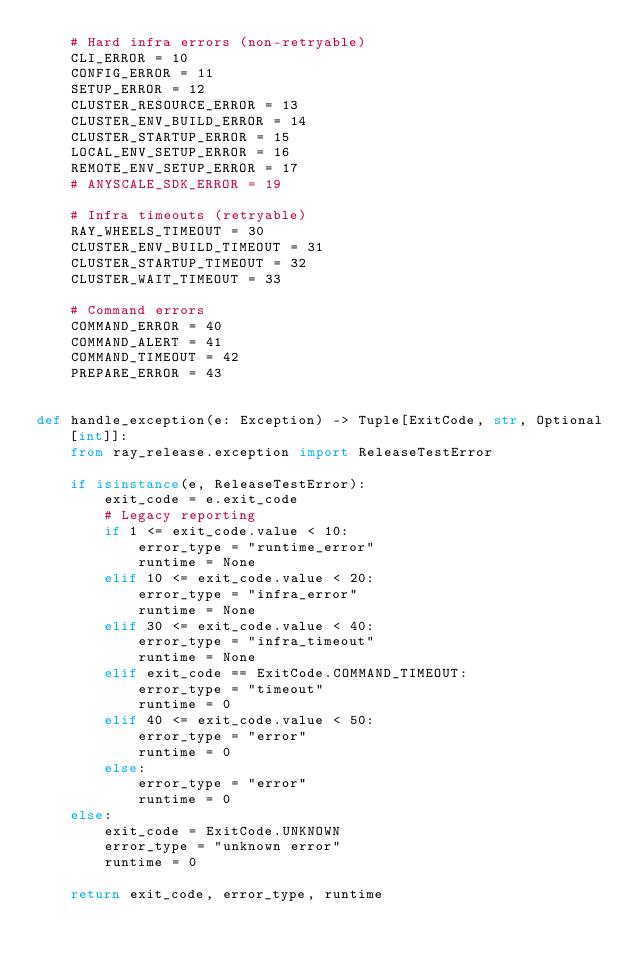<code> <loc_0><loc_0><loc_500><loc_500><_Python_>    # Hard infra errors (non-retryable)
    CLI_ERROR = 10
    CONFIG_ERROR = 11
    SETUP_ERROR = 12
    CLUSTER_RESOURCE_ERROR = 13
    CLUSTER_ENV_BUILD_ERROR = 14
    CLUSTER_STARTUP_ERROR = 15
    LOCAL_ENV_SETUP_ERROR = 16
    REMOTE_ENV_SETUP_ERROR = 17
    # ANYSCALE_SDK_ERROR = 19

    # Infra timeouts (retryable)
    RAY_WHEELS_TIMEOUT = 30
    CLUSTER_ENV_BUILD_TIMEOUT = 31
    CLUSTER_STARTUP_TIMEOUT = 32
    CLUSTER_WAIT_TIMEOUT = 33

    # Command errors
    COMMAND_ERROR = 40
    COMMAND_ALERT = 41
    COMMAND_TIMEOUT = 42
    PREPARE_ERROR = 43


def handle_exception(e: Exception) -> Tuple[ExitCode, str, Optional[int]]:
    from ray_release.exception import ReleaseTestError

    if isinstance(e, ReleaseTestError):
        exit_code = e.exit_code
        # Legacy reporting
        if 1 <= exit_code.value < 10:
            error_type = "runtime_error"
            runtime = None
        elif 10 <= exit_code.value < 20:
            error_type = "infra_error"
            runtime = None
        elif 30 <= exit_code.value < 40:
            error_type = "infra_timeout"
            runtime = None
        elif exit_code == ExitCode.COMMAND_TIMEOUT:
            error_type = "timeout"
            runtime = 0
        elif 40 <= exit_code.value < 50:
            error_type = "error"
            runtime = 0
        else:
            error_type = "error"
            runtime = 0
    else:
        exit_code = ExitCode.UNKNOWN
        error_type = "unknown error"
        runtime = 0

    return exit_code, error_type, runtime
</code> 